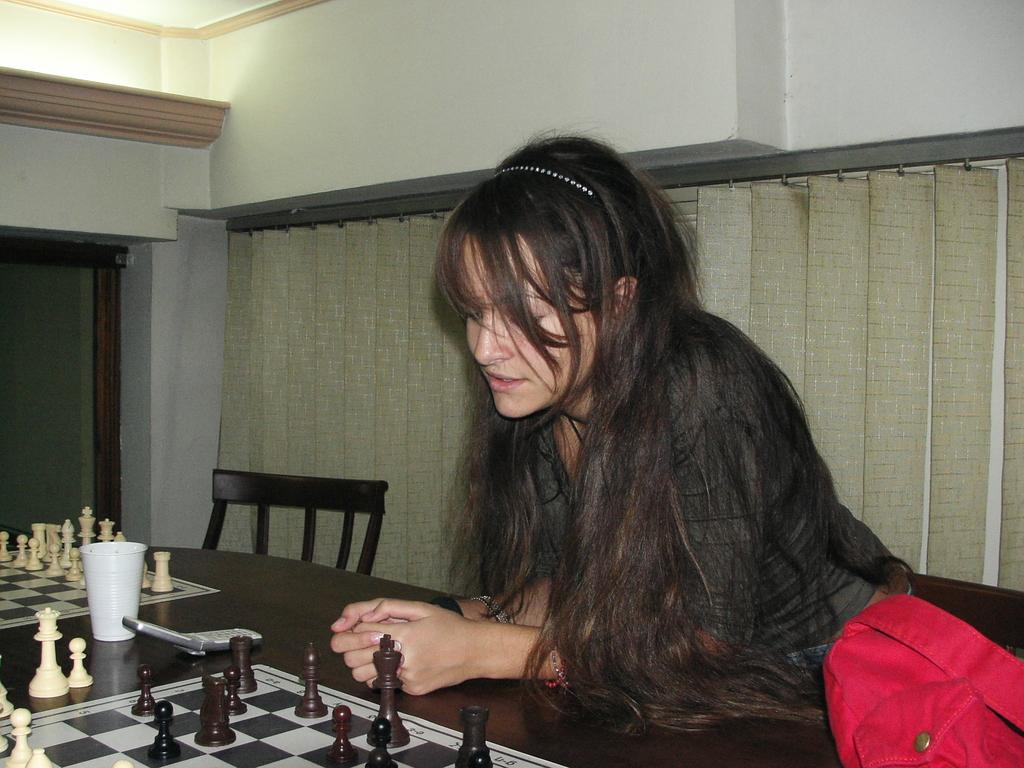Who is the main subject in the image? There is a woman in the image. What is the woman doing in the image? The woman is playing chess. What is the woman sitting on in the image? The woman is seated on a chair. What can be seen in the background of the image? There are blinds visible in the image. What type of leaf is being used as a power source in the image? There is no leaf or power source present in the image; it features a woman playing chess while seated on a chair. What kind of support is the woman leaning on in the image? The woman is seated on a chair, so there is no need for additional support. 